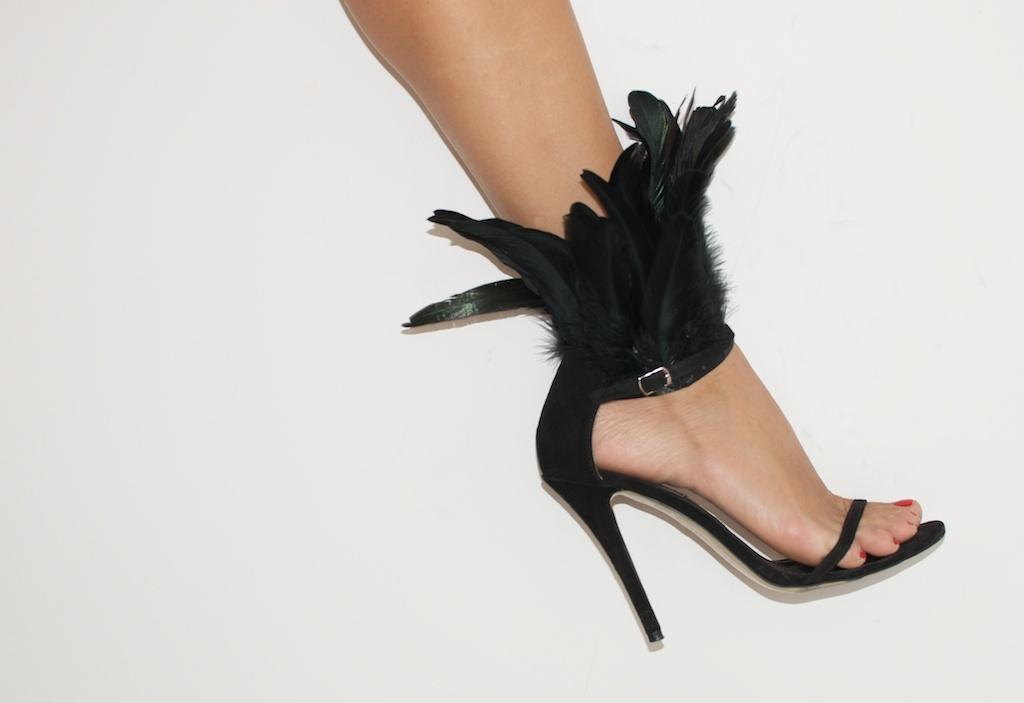What part of a person's body can be seen in the image? There is a leg of a person in the image. What type of footwear is the person wearing? The leg is wearing a sandal. What is the color of the sandal? The sandal is black in color. What type of needle is being exchanged in the morning in the image? There is no needle or exchange of any kind depicted in the image; it only shows a leg wearing a black sandal. 